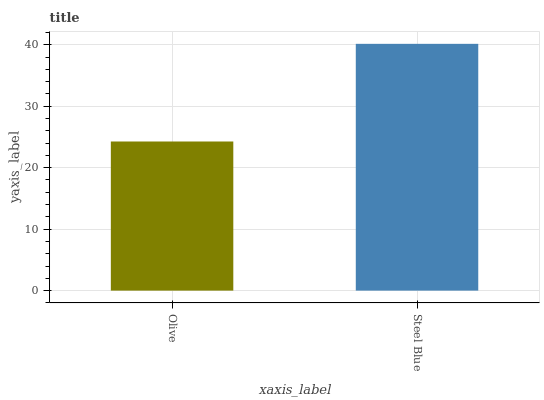Is Olive the minimum?
Answer yes or no. Yes. Is Steel Blue the maximum?
Answer yes or no. Yes. Is Steel Blue the minimum?
Answer yes or no. No. Is Steel Blue greater than Olive?
Answer yes or no. Yes. Is Olive less than Steel Blue?
Answer yes or no. Yes. Is Olive greater than Steel Blue?
Answer yes or no. No. Is Steel Blue less than Olive?
Answer yes or no. No. Is Steel Blue the high median?
Answer yes or no. Yes. Is Olive the low median?
Answer yes or no. Yes. Is Olive the high median?
Answer yes or no. No. Is Steel Blue the low median?
Answer yes or no. No. 